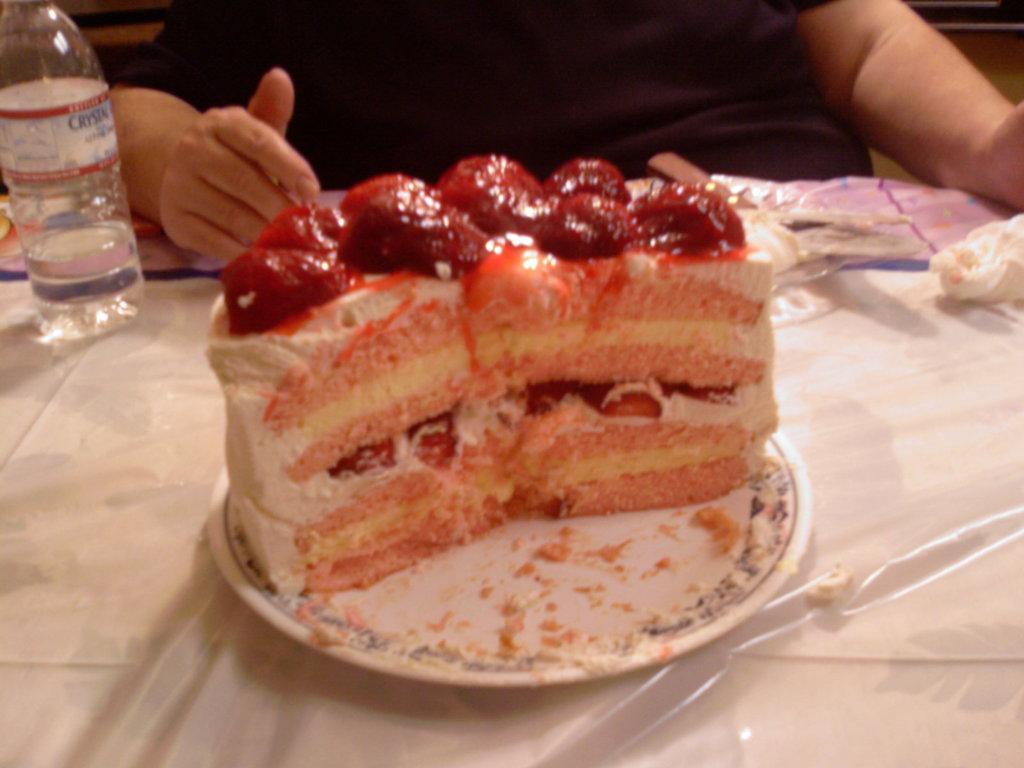Describe this image in one or two sentences. In this picture there is a food placed in the plate on the table. There is a water bottle and a person sitting in front of a table in the chair. 